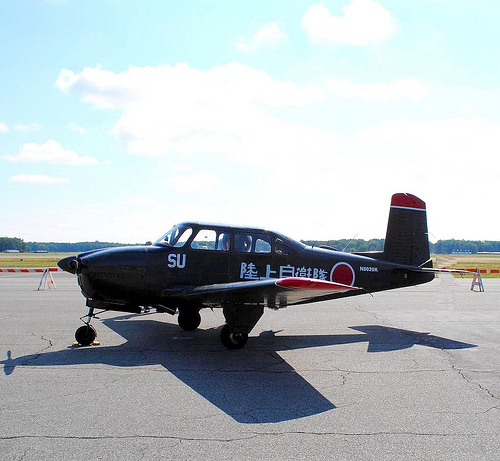Please provide the bounding box coordinate of the region this sentence describes: tree tops on horizon. Tree tops on the horizon fall within the bounding box coordinates [0.0, 0.51, 1.0, 0.54], adding a touch of natural scenery to the background. 